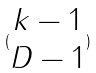<formula> <loc_0><loc_0><loc_500><loc_500>( \begin{matrix} k - 1 \\ D - 1 \end{matrix} )</formula> 